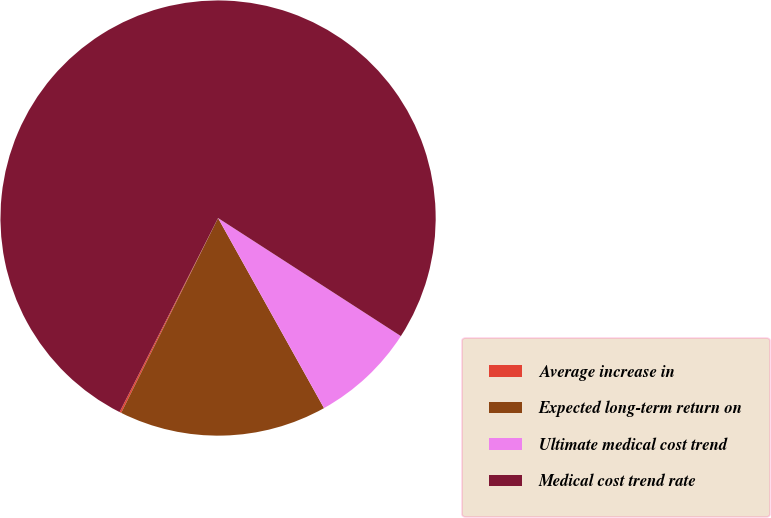<chart> <loc_0><loc_0><loc_500><loc_500><pie_chart><fcel>Average increase in<fcel>Expected long-term return on<fcel>Ultimate medical cost trend<fcel>Medical cost trend rate<nl><fcel>0.13%<fcel>15.44%<fcel>7.78%<fcel>76.65%<nl></chart> 